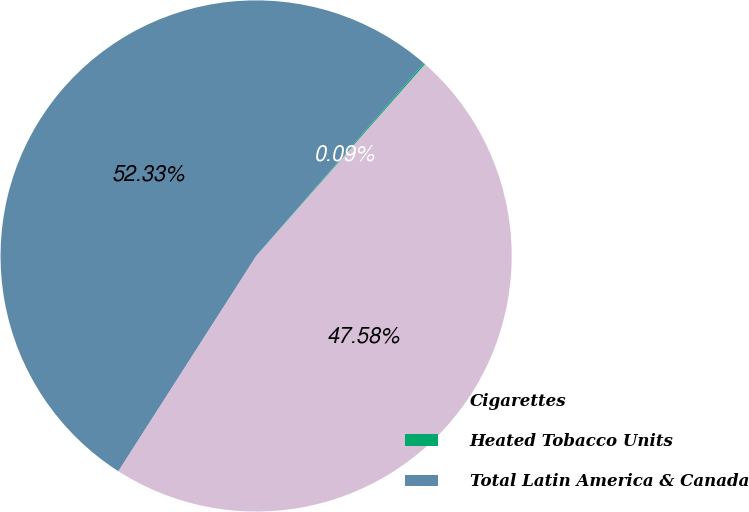<chart> <loc_0><loc_0><loc_500><loc_500><pie_chart><fcel>Cigarettes<fcel>Heated Tobacco Units<fcel>Total Latin America & Canada<nl><fcel>47.58%<fcel>0.09%<fcel>52.34%<nl></chart> 